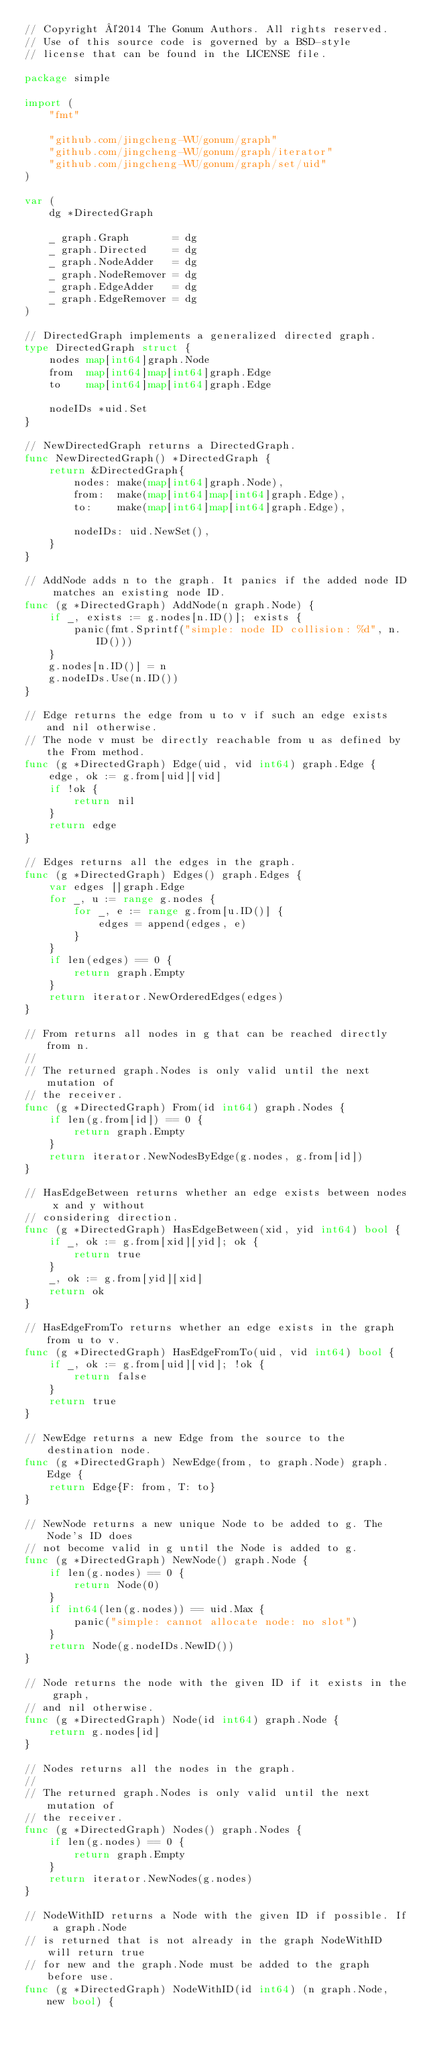<code> <loc_0><loc_0><loc_500><loc_500><_Go_>// Copyright ©2014 The Gonum Authors. All rights reserved.
// Use of this source code is governed by a BSD-style
// license that can be found in the LICENSE file.

package simple

import (
	"fmt"

	"github.com/jingcheng-WU/gonum/graph"
	"github.com/jingcheng-WU/gonum/graph/iterator"
	"github.com/jingcheng-WU/gonum/graph/set/uid"
)

var (
	dg *DirectedGraph

	_ graph.Graph       = dg
	_ graph.Directed    = dg
	_ graph.NodeAdder   = dg
	_ graph.NodeRemover = dg
	_ graph.EdgeAdder   = dg
	_ graph.EdgeRemover = dg
)

// DirectedGraph implements a generalized directed graph.
type DirectedGraph struct {
	nodes map[int64]graph.Node
	from  map[int64]map[int64]graph.Edge
	to    map[int64]map[int64]graph.Edge

	nodeIDs *uid.Set
}

// NewDirectedGraph returns a DirectedGraph.
func NewDirectedGraph() *DirectedGraph {
	return &DirectedGraph{
		nodes: make(map[int64]graph.Node),
		from:  make(map[int64]map[int64]graph.Edge),
		to:    make(map[int64]map[int64]graph.Edge),

		nodeIDs: uid.NewSet(),
	}
}

// AddNode adds n to the graph. It panics if the added node ID matches an existing node ID.
func (g *DirectedGraph) AddNode(n graph.Node) {
	if _, exists := g.nodes[n.ID()]; exists {
		panic(fmt.Sprintf("simple: node ID collision: %d", n.ID()))
	}
	g.nodes[n.ID()] = n
	g.nodeIDs.Use(n.ID())
}

// Edge returns the edge from u to v if such an edge exists and nil otherwise.
// The node v must be directly reachable from u as defined by the From method.
func (g *DirectedGraph) Edge(uid, vid int64) graph.Edge {
	edge, ok := g.from[uid][vid]
	if !ok {
		return nil
	}
	return edge
}

// Edges returns all the edges in the graph.
func (g *DirectedGraph) Edges() graph.Edges {
	var edges []graph.Edge
	for _, u := range g.nodes {
		for _, e := range g.from[u.ID()] {
			edges = append(edges, e)
		}
	}
	if len(edges) == 0 {
		return graph.Empty
	}
	return iterator.NewOrderedEdges(edges)
}

// From returns all nodes in g that can be reached directly from n.
//
// The returned graph.Nodes is only valid until the next mutation of
// the receiver.
func (g *DirectedGraph) From(id int64) graph.Nodes {
	if len(g.from[id]) == 0 {
		return graph.Empty
	}
	return iterator.NewNodesByEdge(g.nodes, g.from[id])
}

// HasEdgeBetween returns whether an edge exists between nodes x and y without
// considering direction.
func (g *DirectedGraph) HasEdgeBetween(xid, yid int64) bool {
	if _, ok := g.from[xid][yid]; ok {
		return true
	}
	_, ok := g.from[yid][xid]
	return ok
}

// HasEdgeFromTo returns whether an edge exists in the graph from u to v.
func (g *DirectedGraph) HasEdgeFromTo(uid, vid int64) bool {
	if _, ok := g.from[uid][vid]; !ok {
		return false
	}
	return true
}

// NewEdge returns a new Edge from the source to the destination node.
func (g *DirectedGraph) NewEdge(from, to graph.Node) graph.Edge {
	return Edge{F: from, T: to}
}

// NewNode returns a new unique Node to be added to g. The Node's ID does
// not become valid in g until the Node is added to g.
func (g *DirectedGraph) NewNode() graph.Node {
	if len(g.nodes) == 0 {
		return Node(0)
	}
	if int64(len(g.nodes)) == uid.Max {
		panic("simple: cannot allocate node: no slot")
	}
	return Node(g.nodeIDs.NewID())
}

// Node returns the node with the given ID if it exists in the graph,
// and nil otherwise.
func (g *DirectedGraph) Node(id int64) graph.Node {
	return g.nodes[id]
}

// Nodes returns all the nodes in the graph.
//
// The returned graph.Nodes is only valid until the next mutation of
// the receiver.
func (g *DirectedGraph) Nodes() graph.Nodes {
	if len(g.nodes) == 0 {
		return graph.Empty
	}
	return iterator.NewNodes(g.nodes)
}

// NodeWithID returns a Node with the given ID if possible. If a graph.Node
// is returned that is not already in the graph NodeWithID will return true
// for new and the graph.Node must be added to the graph before use.
func (g *DirectedGraph) NodeWithID(id int64) (n graph.Node, new bool) {</code> 